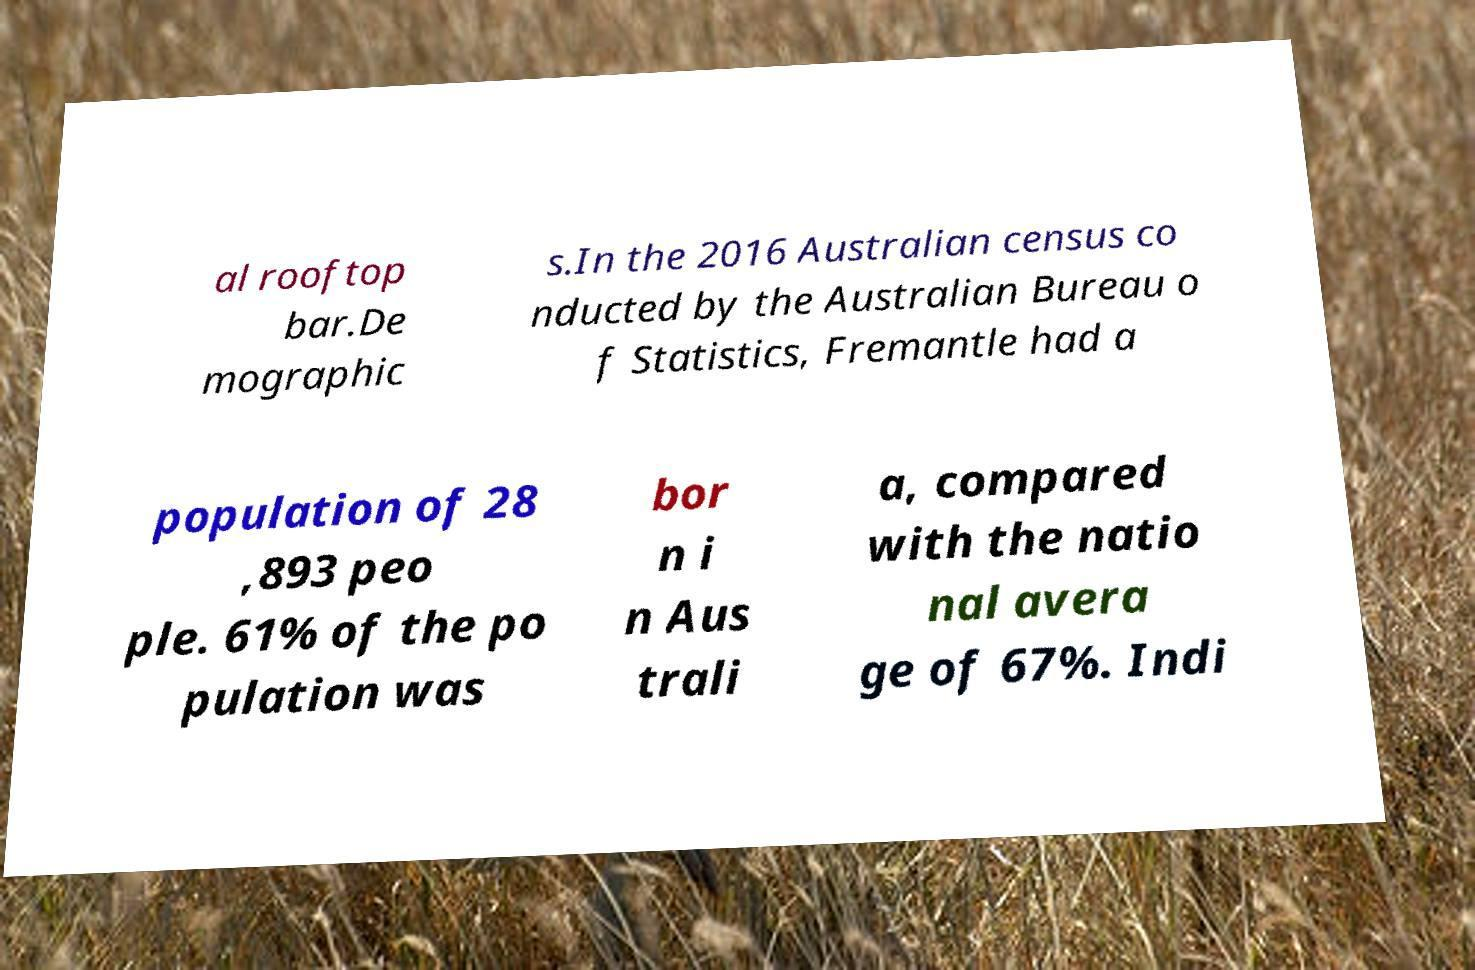Can you accurately transcribe the text from the provided image for me? al rooftop bar.De mographic s.In the 2016 Australian census co nducted by the Australian Bureau o f Statistics, Fremantle had a population of 28 ,893 peo ple. 61% of the po pulation was bor n i n Aus trali a, compared with the natio nal avera ge of 67%. Indi 